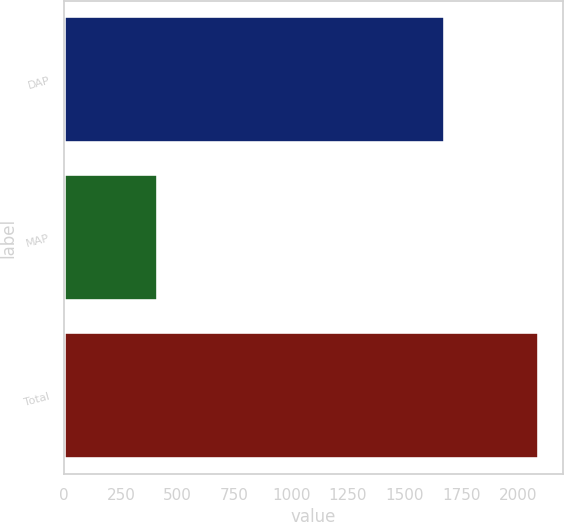Convert chart to OTSL. <chart><loc_0><loc_0><loc_500><loc_500><bar_chart><fcel>DAP<fcel>MAP<fcel>Total<nl><fcel>1676<fcel>414<fcel>2090<nl></chart> 